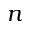<formula> <loc_0><loc_0><loc_500><loc_500>n</formula> 